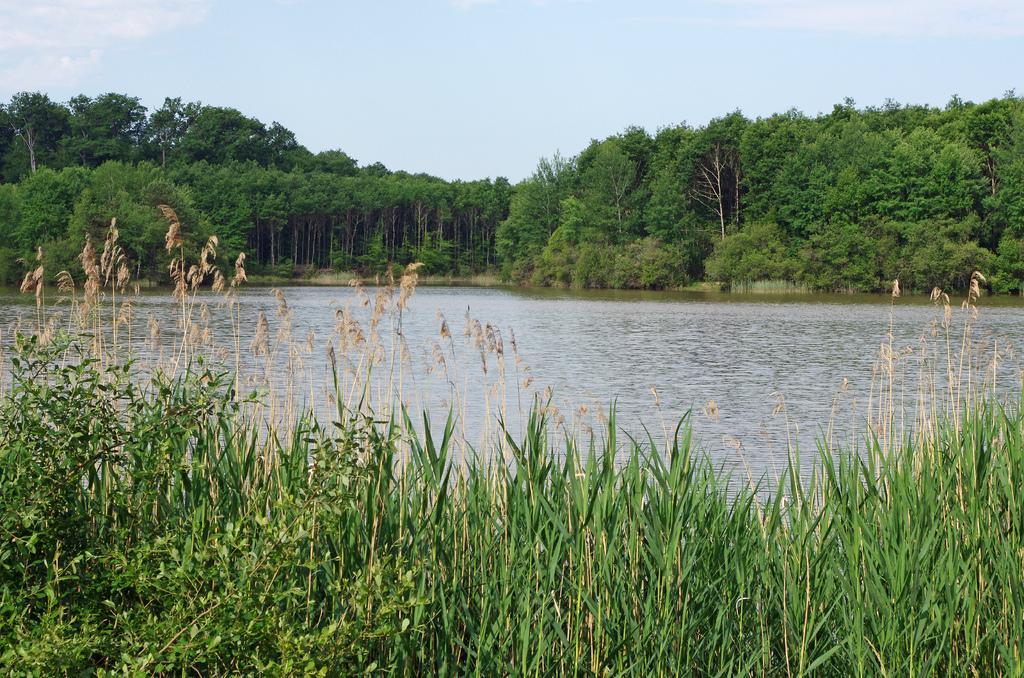In one or two sentences, can you explain what this image depicts? In this image I can see the grass. I can see the water. In the background, I can see the trees and clouds in the sky. 